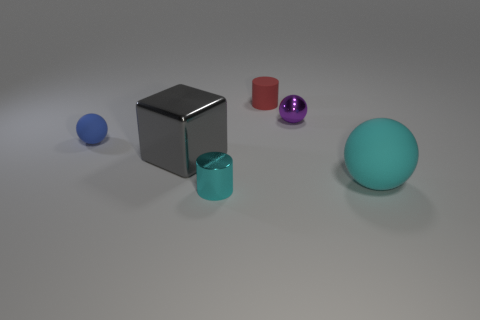Add 3 big blocks. How many objects exist? 9 Subtract all blocks. How many objects are left? 5 Add 5 green metallic cylinders. How many green metallic cylinders exist? 5 Subtract 1 cyan spheres. How many objects are left? 5 Subtract all small objects. Subtract all red cylinders. How many objects are left? 1 Add 1 blue balls. How many blue balls are left? 2 